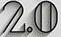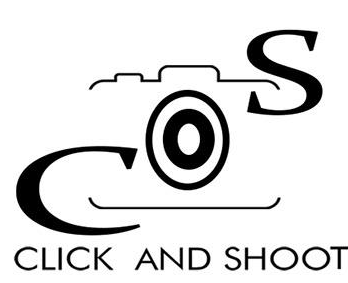What words are shown in these images in order, separated by a semicolon? 2.0; COS 